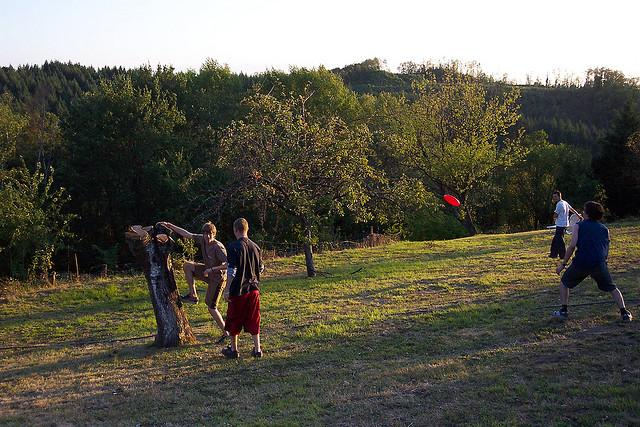Why does the boy have his leg on the tree? Please explain your reasoning. to climb. More than likely boys like to climb on trees. 